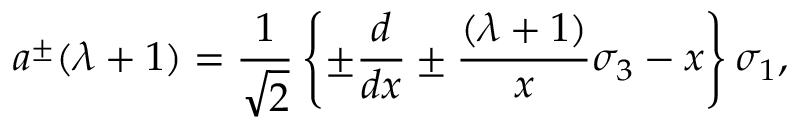<formula> <loc_0><loc_0><loc_500><loc_500>a ^ { \pm } ( \lambda + 1 ) = { \frac { 1 } { \sqrt { 2 } } } \left \{ \pm { \frac { d } { d x } } \pm { \frac { ( \lambda + 1 ) } { x } } \sigma _ { 3 } - x \right \} \sigma _ { 1 } ,</formula> 